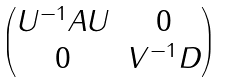<formula> <loc_0><loc_0><loc_500><loc_500>\begin{pmatrix} U ^ { - 1 } A U & 0 \\ 0 & V ^ { - 1 } D \end{pmatrix}</formula> 